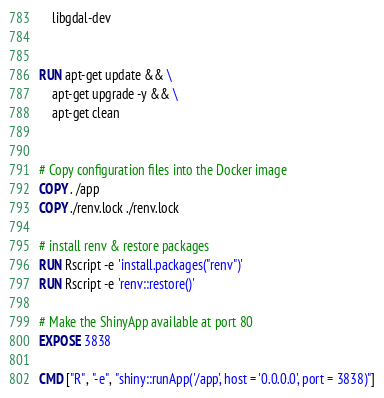<code> <loc_0><loc_0><loc_500><loc_500><_Dockerfile_>    libgdal-dev


RUN apt-get update && \
    apt-get upgrade -y && \
    apt-get clean


# Copy configuration files into the Docker image
COPY . /app
COPY ./renv.lock ./renv.lock

# install renv & restore packages
RUN Rscript -e 'install.packages("renv")'
RUN Rscript -e 'renv::restore()'

# Make the ShinyApp available at port 80
EXPOSE 3838

CMD ["R", "-e", "shiny::runApp('/app', host = '0.0.0.0', port = 3838)"]</code> 